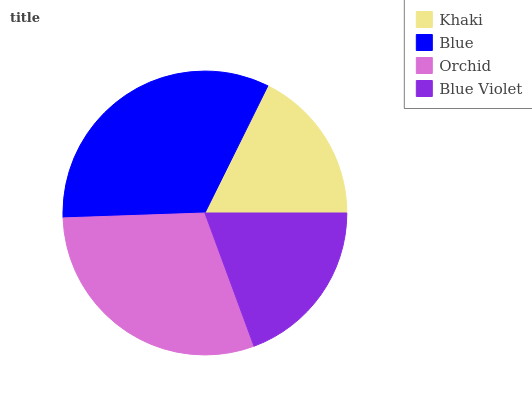Is Khaki the minimum?
Answer yes or no. Yes. Is Blue the maximum?
Answer yes or no. Yes. Is Orchid the minimum?
Answer yes or no. No. Is Orchid the maximum?
Answer yes or no. No. Is Blue greater than Orchid?
Answer yes or no. Yes. Is Orchid less than Blue?
Answer yes or no. Yes. Is Orchid greater than Blue?
Answer yes or no. No. Is Blue less than Orchid?
Answer yes or no. No. Is Orchid the high median?
Answer yes or no. Yes. Is Blue Violet the low median?
Answer yes or no. Yes. Is Khaki the high median?
Answer yes or no. No. Is Khaki the low median?
Answer yes or no. No. 